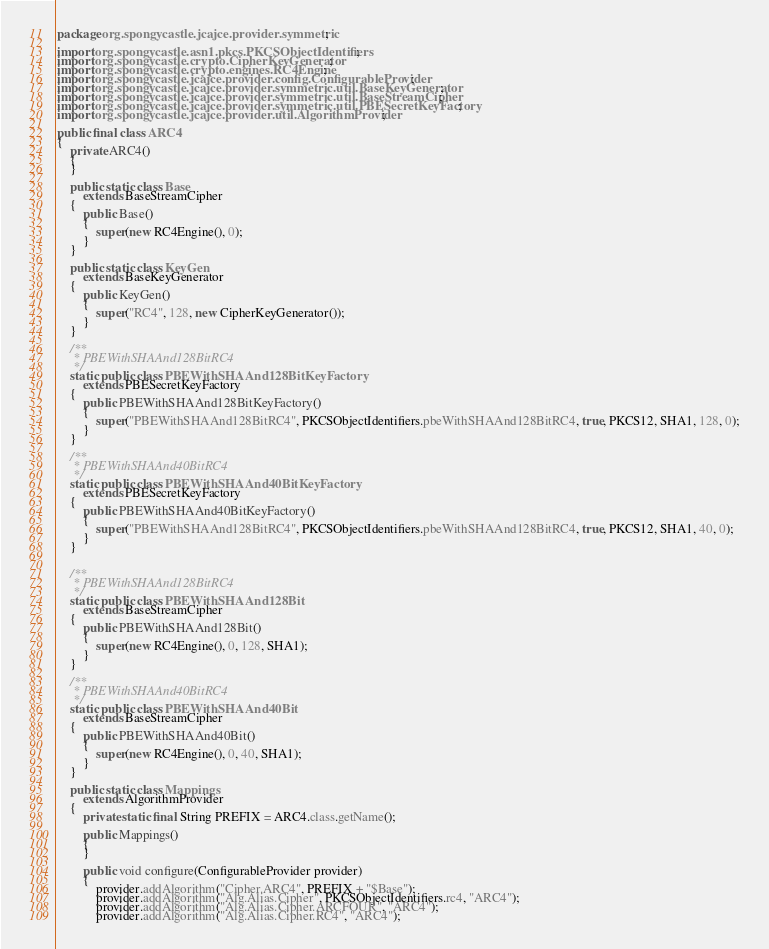<code> <loc_0><loc_0><loc_500><loc_500><_Java_>package org.spongycastle.jcajce.provider.symmetric;

import org.spongycastle.asn1.pkcs.PKCSObjectIdentifiers;
import org.spongycastle.crypto.CipherKeyGenerator;
import org.spongycastle.crypto.engines.RC4Engine;
import org.spongycastle.jcajce.provider.config.ConfigurableProvider;
import org.spongycastle.jcajce.provider.symmetric.util.BaseKeyGenerator;
import org.spongycastle.jcajce.provider.symmetric.util.BaseStreamCipher;
import org.spongycastle.jcajce.provider.symmetric.util.PBESecretKeyFactory;
import org.spongycastle.jcajce.provider.util.AlgorithmProvider;

public final class ARC4
{
    private ARC4()
    {
    }
    
    public static class Base
        extends BaseStreamCipher
    {
        public Base()
        {
            super(new RC4Engine(), 0);
        }
    }

    public static class KeyGen
        extends BaseKeyGenerator
    {
        public KeyGen()
        {
            super("RC4", 128, new CipherKeyGenerator());
        }
    }

    /**
     * PBEWithSHAAnd128BitRC4
     */
    static public class PBEWithSHAAnd128BitKeyFactory
        extends PBESecretKeyFactory
    {
        public PBEWithSHAAnd128BitKeyFactory()
        {
            super("PBEWithSHAAnd128BitRC4", PKCSObjectIdentifiers.pbeWithSHAAnd128BitRC4, true, PKCS12, SHA1, 128, 0);
        }
    }

    /**
     * PBEWithSHAAnd40BitRC4
     */
    static public class PBEWithSHAAnd40BitKeyFactory
        extends PBESecretKeyFactory
    {
        public PBEWithSHAAnd40BitKeyFactory()
        {
            super("PBEWithSHAAnd128BitRC4", PKCSObjectIdentifiers.pbeWithSHAAnd128BitRC4, true, PKCS12, SHA1, 40, 0);
        }
    }


    /**
     * PBEWithSHAAnd128BitRC4
     */
    static public class PBEWithSHAAnd128Bit
        extends BaseStreamCipher
    {
        public PBEWithSHAAnd128Bit()
        {
            super(new RC4Engine(), 0, 128, SHA1);
        }
    }

    /**
     * PBEWithSHAAnd40BitRC4
     */
    static public class PBEWithSHAAnd40Bit
        extends BaseStreamCipher
    {
        public PBEWithSHAAnd40Bit()
        {
            super(new RC4Engine(), 0, 40, SHA1);
        }
    }

    public static class Mappings
        extends AlgorithmProvider
    {
        private static final String PREFIX = ARC4.class.getName();

        public Mappings()
        {
        }

        public void configure(ConfigurableProvider provider)
        {
            provider.addAlgorithm("Cipher.ARC4", PREFIX + "$Base");
            provider.addAlgorithm("Alg.Alias.Cipher", PKCSObjectIdentifiers.rc4, "ARC4");
            provider.addAlgorithm("Alg.Alias.Cipher.ARCFOUR", "ARC4");
            provider.addAlgorithm("Alg.Alias.Cipher.RC4", "ARC4");</code> 